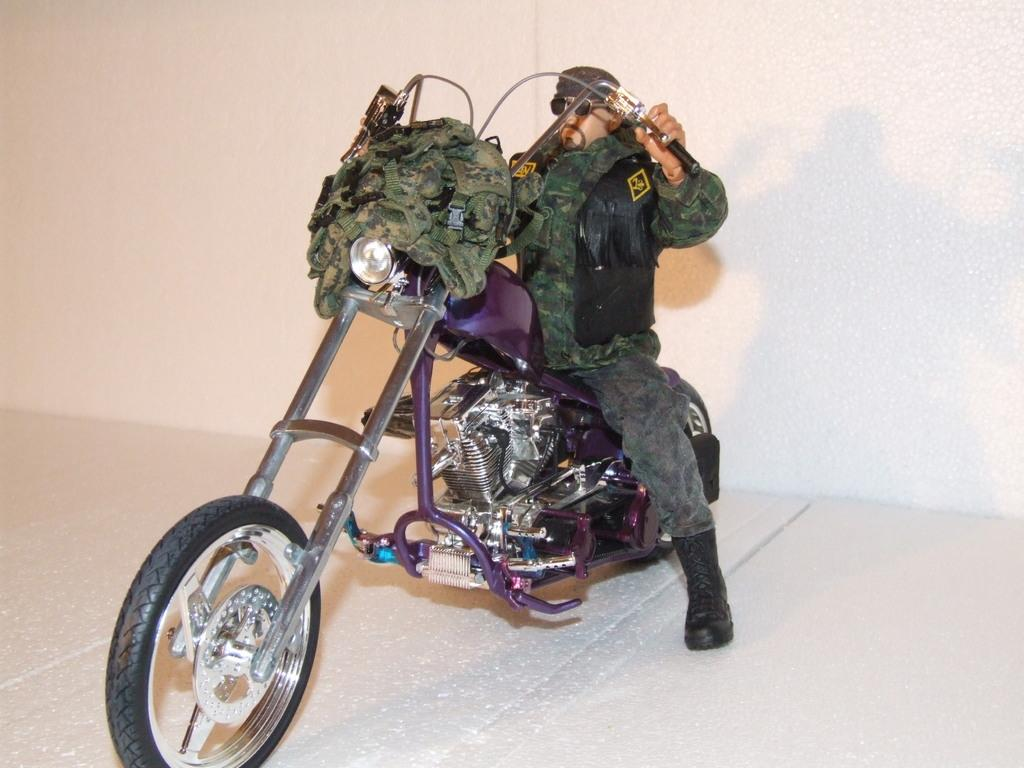Who is present in the image? There is a person in the image. What is the person doing in the image? The person is sitting on a motorbike. What is the position of the motorbike in the image? The motorbike is on the ground. What type of clothing is the person wearing in the image? The person is wearing a jacket, goggles, and a cap. What type of fan can be seen in the image? There is no fan present in the image. How many apples are visible in the image? There are no apples present in the image. 